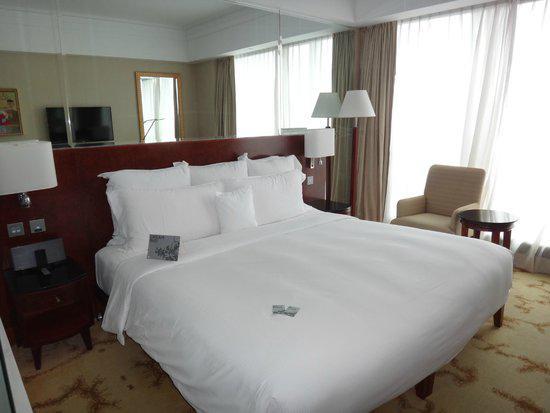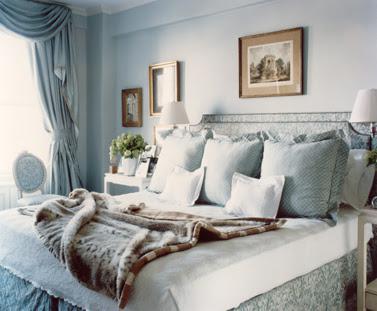The first image is the image on the left, the second image is the image on the right. For the images displayed, is the sentence "there is exactly one lamp in one of the images." factually correct? Answer yes or no. No. The first image is the image on the left, the second image is the image on the right. Assess this claim about the two images: "All bedding and pillows in one image are white.". Correct or not? Answer yes or no. Yes. 